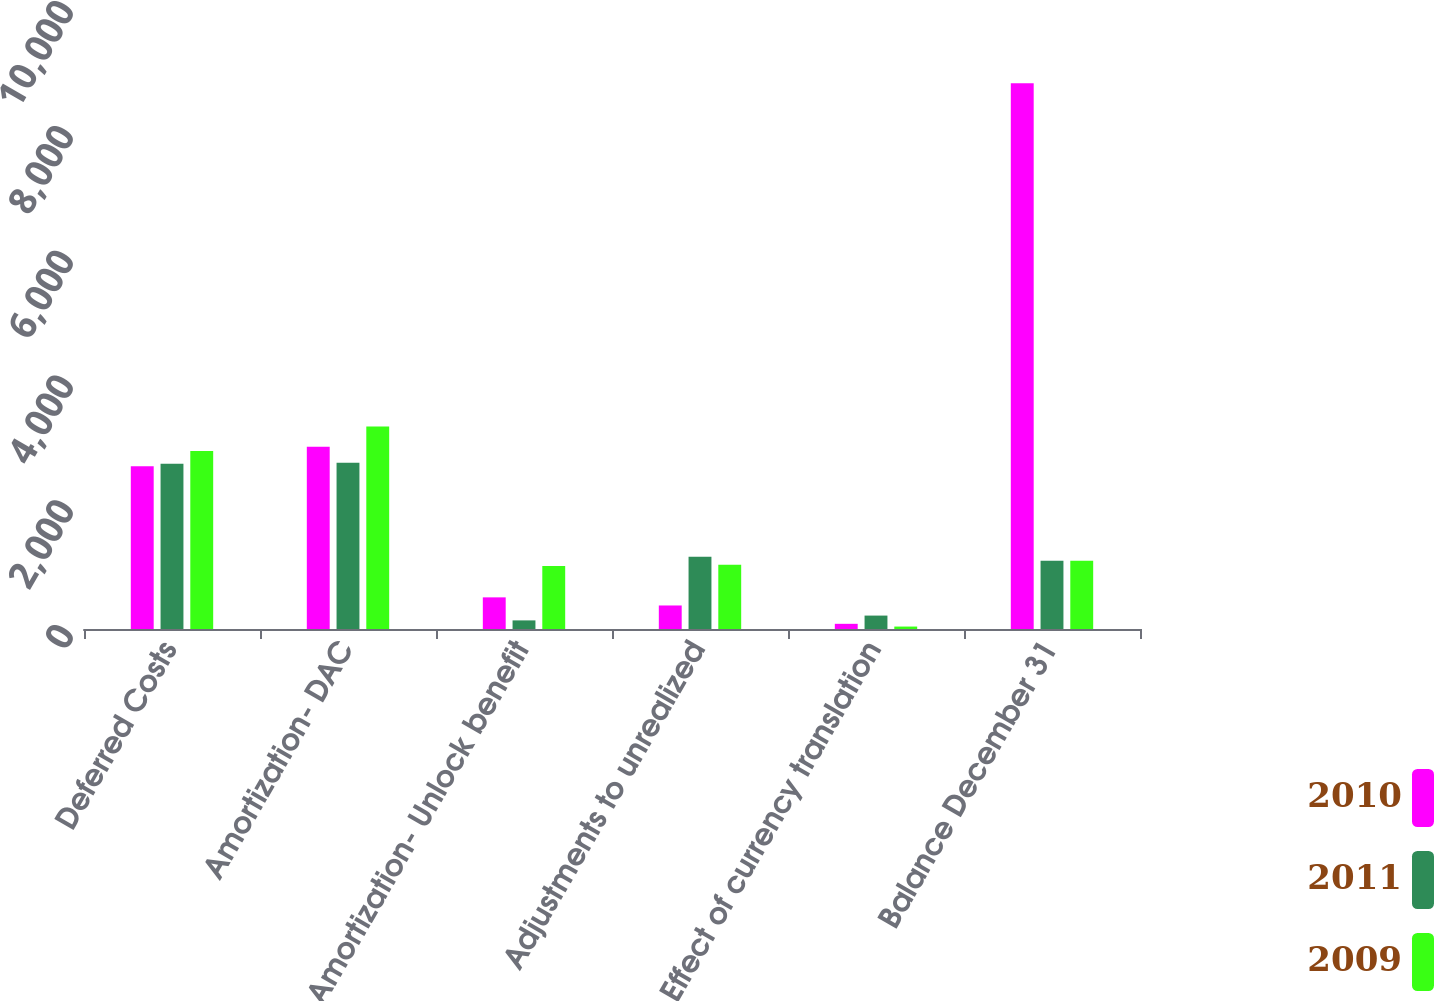Convert chart. <chart><loc_0><loc_0><loc_500><loc_500><stacked_bar_chart><ecel><fcel>Deferred Costs<fcel>Amortization- DAC<fcel>Amortization- Unlock benefit<fcel>Adjustments to unrealized<fcel>Effect of currency translation<fcel>Balance December 31<nl><fcel>2010<fcel>2608<fcel>2920<fcel>507<fcel>377<fcel>83<fcel>8744<nl><fcel>2011<fcel>2648<fcel>2665<fcel>138<fcel>1159<fcel>215<fcel>1095<nl><fcel>2009<fcel>2853<fcel>3247<fcel>1010<fcel>1031<fcel>39<fcel>1095<nl></chart> 